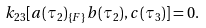Convert formula to latex. <formula><loc_0><loc_0><loc_500><loc_500>k _ { 2 3 } [ a ( \tau _ { 2 } ) _ { \{ F \} } b ( \tau _ { 2 } ) , c ( \tau _ { 3 } ) ] = 0 .</formula> 